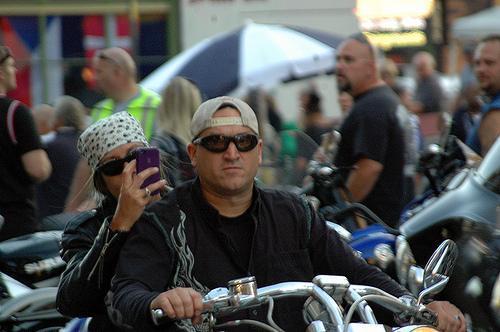How many people are on the front motorcycle?
Give a very brief answer. 2. 